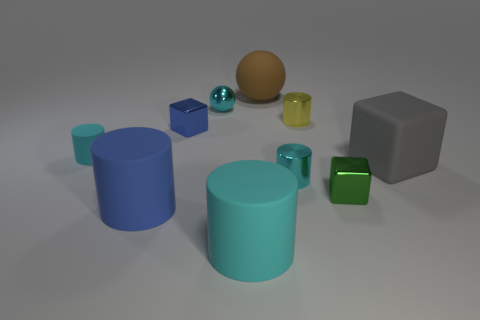Subtract all blue cylinders. How many cylinders are left? 4 Subtract all balls. How many objects are left? 8 Subtract all gray blocks. How many blocks are left? 2 Subtract 1 spheres. How many spheres are left? 1 Subtract all red cylinders. Subtract all blue cubes. How many cylinders are left? 5 Subtract all purple balls. How many yellow cylinders are left? 1 Subtract all tiny green metallic things. Subtract all gray rubber objects. How many objects are left? 8 Add 8 cyan shiny spheres. How many cyan shiny spheres are left? 9 Add 7 large blue matte things. How many large blue matte things exist? 8 Subtract 0 red cylinders. How many objects are left? 10 